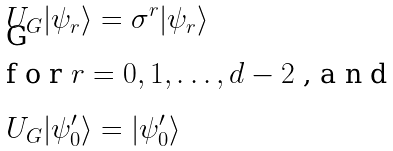<formula> <loc_0><loc_0><loc_500><loc_500>U _ { G } | \psi _ { r } \rangle & = \sigma ^ { r } | \psi _ { r } \rangle \\ \intertext { f o r $ r = 0 , 1 , \dots , d - 2 $ , a n d } U _ { G } | \psi ^ { \prime } _ { 0 } \rangle & = | \psi ^ { \prime } _ { 0 } \rangle</formula> 